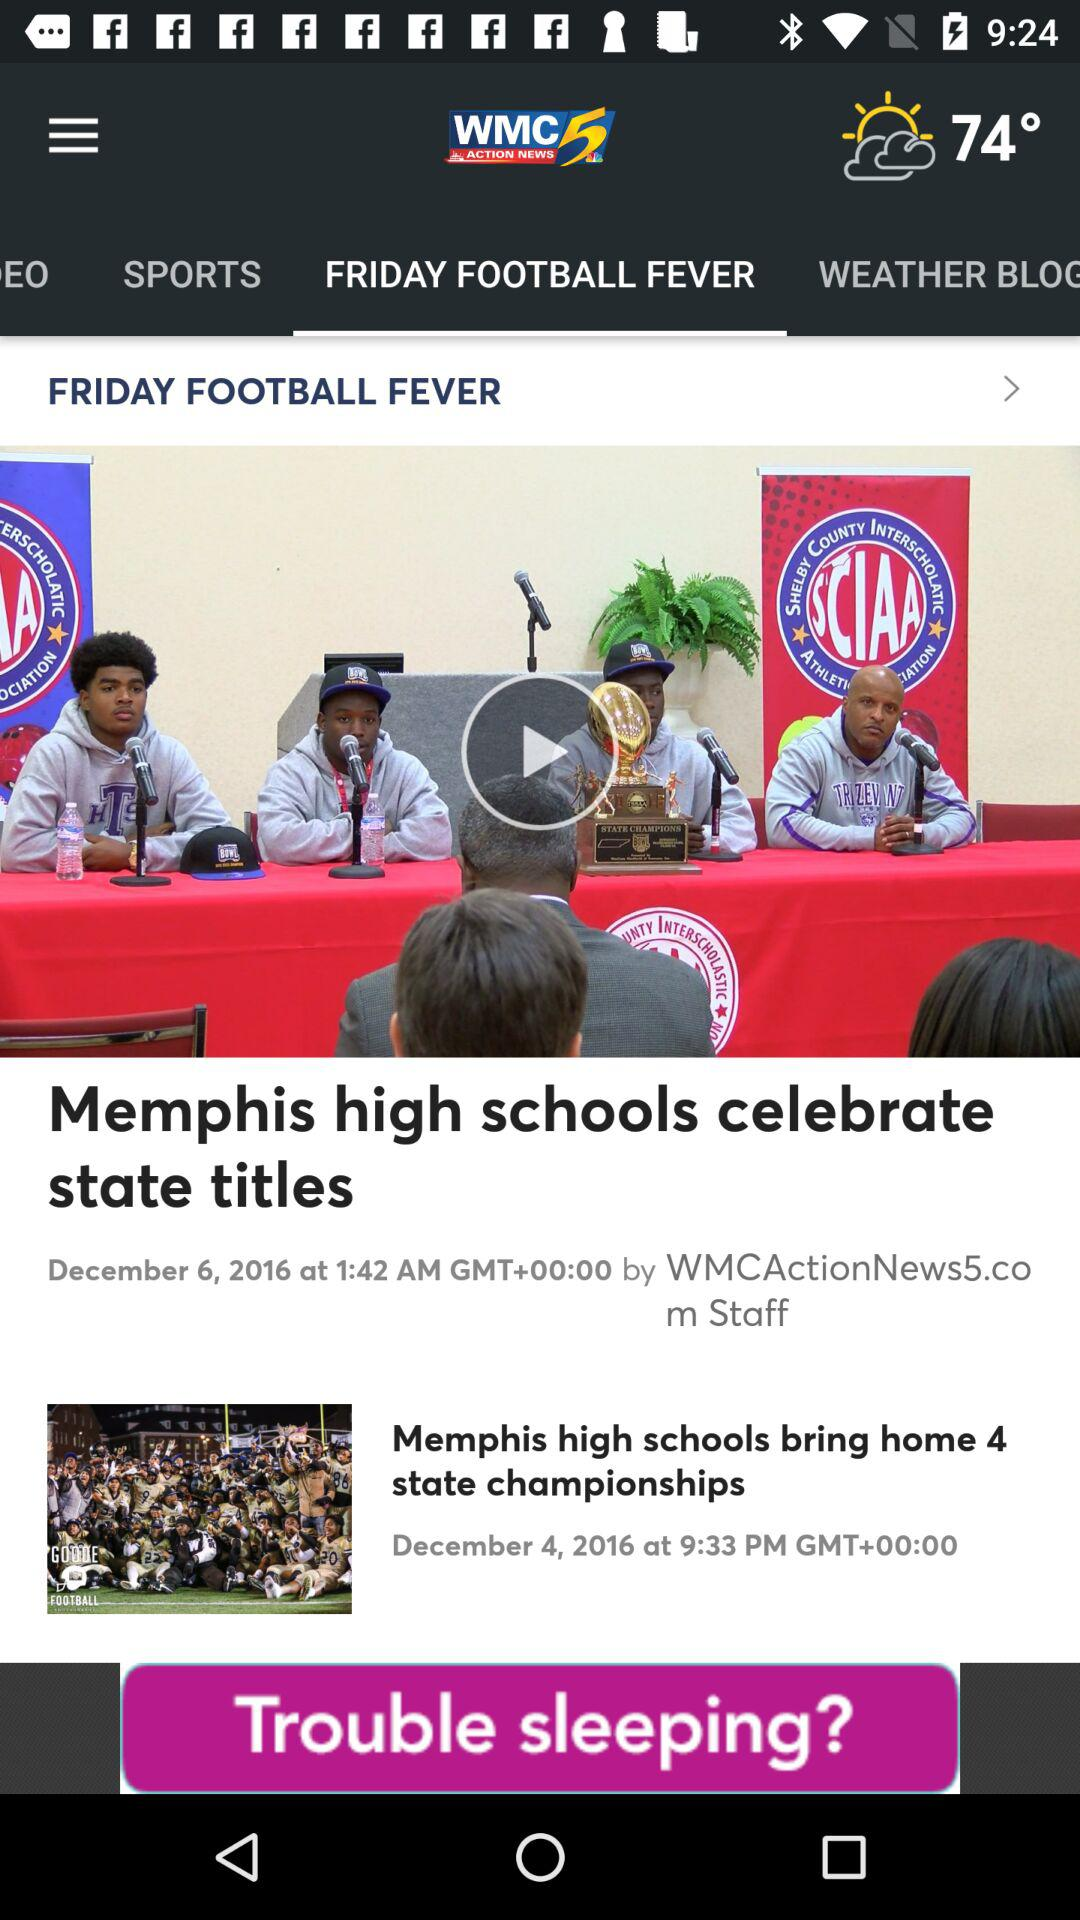What is the weather forecast?
When the provided information is insufficient, respond with <no answer>. <no answer> 